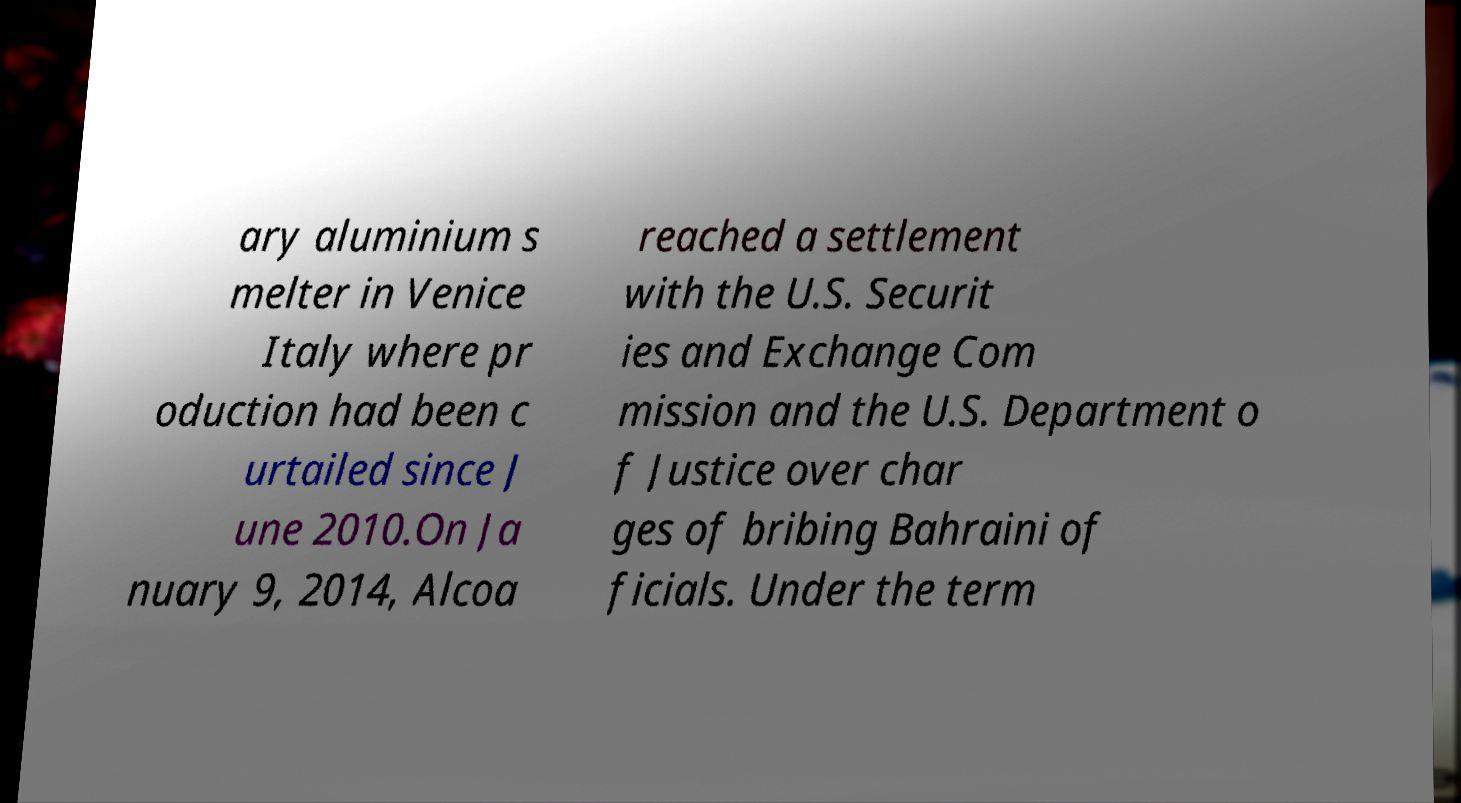I need the written content from this picture converted into text. Can you do that? ary aluminium s melter in Venice Italy where pr oduction had been c urtailed since J une 2010.On Ja nuary 9, 2014, Alcoa reached a settlement with the U.S. Securit ies and Exchange Com mission and the U.S. Department o f Justice over char ges of bribing Bahraini of ficials. Under the term 